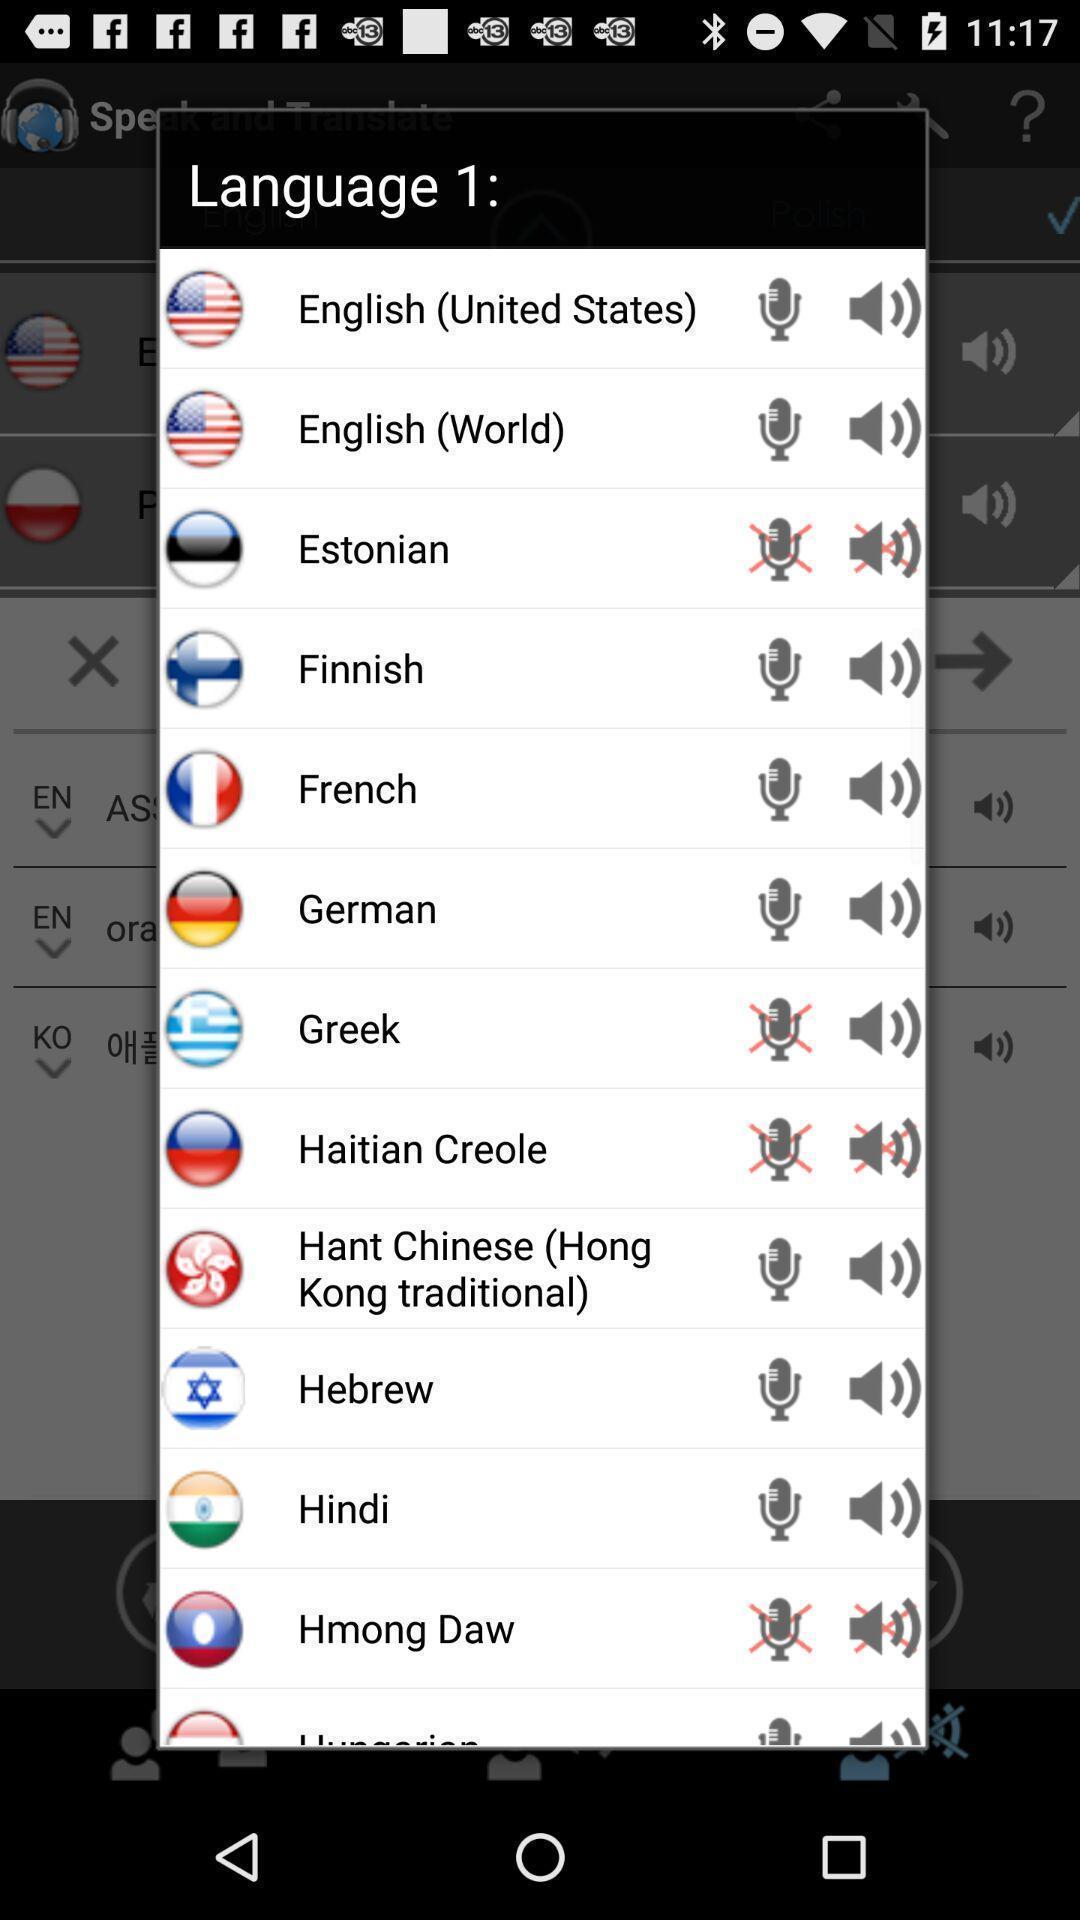What can you discern from this picture? Pop-up showing about list of languages. 